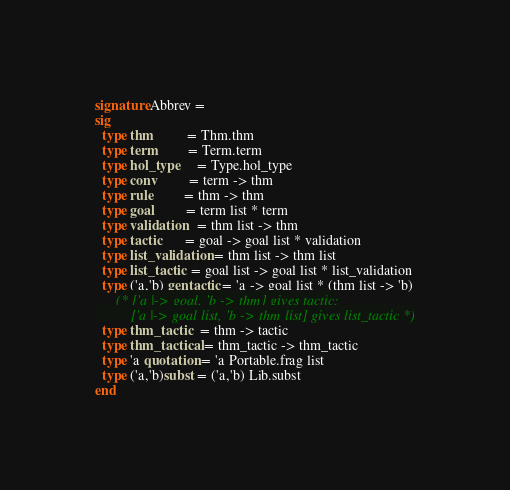Convert code to text. <code><loc_0><loc_0><loc_500><loc_500><_SML_>signature Abbrev =
sig
  type thm          = Thm.thm
  type term         = Term.term
  type hol_type     = Type.hol_type
  type conv         = term -> thm
  type rule         = thm -> thm
  type goal         = term list * term
  type validation   = thm list -> thm
  type tactic       = goal -> goal list * validation
  type list_validation = thm list -> thm list
  type list_tactic  = goal list -> goal list * list_validation
  type ('a,'b) gentactic = 'a -> goal list * (thm list -> 'b)
      (* ['a |-> goal, 'b -> thm] gives tactic;
         ['a |-> goal list, 'b -> thm list] gives list_tactic *)
  type thm_tactic   = thm -> tactic
  type thm_tactical = thm_tactic -> thm_tactic
  type 'a quotation = 'a Portable.frag list
  type ('a,'b)subst = ('a,'b) Lib.subst
end
</code> 